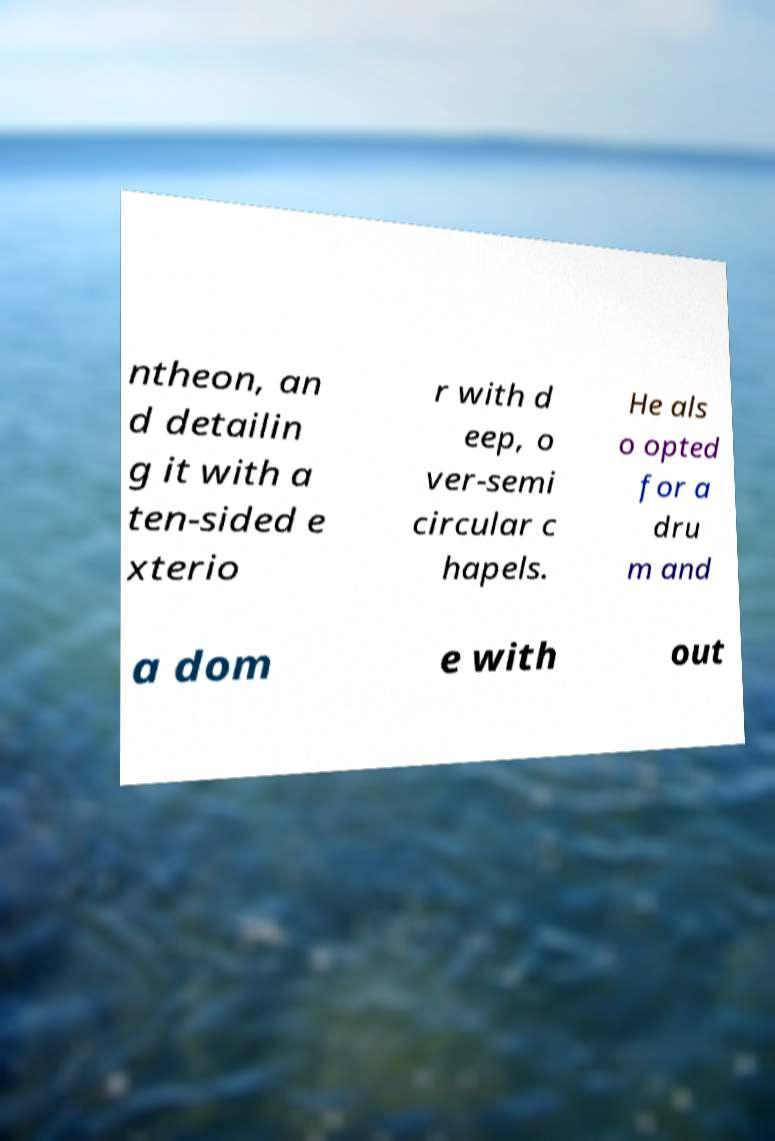I need the written content from this picture converted into text. Can you do that? ntheon, an d detailin g it with a ten-sided e xterio r with d eep, o ver-semi circular c hapels. He als o opted for a dru m and a dom e with out 